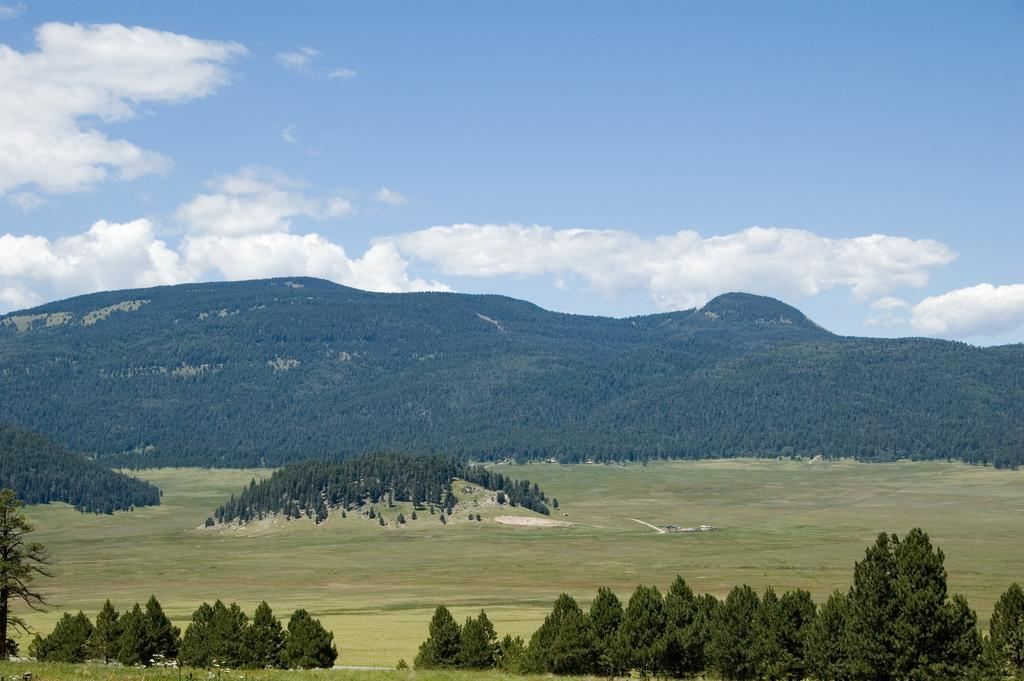What type of vegetation can be seen in the image? There are plants and trees visible in the image. What is on the surface in the image? There is grass on the surface in the image. What can be seen in the background of the image? The sky is visible in the background of the image. What flavor of dinner is being served in the image? There is no dinner present in the image, so it is not possible to determine the flavor. How many legs can be seen on the plants in the image? Plants do not have legs, so this question cannot be answered. 